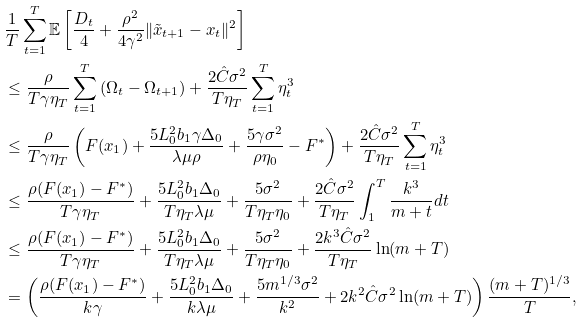<formula> <loc_0><loc_0><loc_500><loc_500>& \frac { 1 } { T } \sum _ { t = 1 } ^ { T } \mathbb { E } \left [ \frac { D _ { t } } { 4 } + \frac { \rho ^ { 2 } } { 4 \gamma ^ { 2 } } \| \tilde { x } _ { t + 1 } - x _ { t } \| ^ { 2 } \right ] \\ & \leq \frac { \rho } { T \gamma \eta _ { T } } \sum _ { t = 1 } ^ { T } \left ( \Omega _ { t } - \Omega _ { t + 1 } \right ) + \frac { 2 \hat { C } \sigma ^ { 2 } } { T \eta _ { T } } \sum _ { t = 1 } ^ { T } \eta ^ { 3 } _ { t } \\ & \leq \frac { \rho } { T \gamma \eta _ { T } } \left ( F ( x _ { 1 } ) + \frac { 5 L ^ { 2 } _ { 0 } b _ { 1 } \gamma \Delta _ { 0 } } { \lambda \mu \rho } + \frac { 5 \gamma \sigma ^ { 2 } } { \rho \eta _ { 0 } } - F ^ { * } \right ) + \frac { 2 \hat { C } \sigma ^ { 2 } } { T \eta _ { T } } \sum _ { t = 1 } ^ { T } \eta ^ { 3 } _ { t } \\ & \leq \frac { \rho ( F ( x _ { 1 } ) - F ^ { * } ) } { T \gamma \eta _ { T } } + \frac { 5 L ^ { 2 } _ { 0 } b _ { 1 } \Delta _ { 0 } } { T \eta _ { T } \lambda \mu } + \frac { 5 \sigma ^ { 2 } } { T \eta _ { T } \eta _ { 0 } } + \frac { 2 \hat { C } \sigma ^ { 2 } } { T \eta _ { T } } \int ^ { T } _ { 1 } \frac { k ^ { 3 } } { m + t } d t \\ & \leq \frac { \rho ( F ( x _ { 1 } ) - F ^ { * } ) } { T \gamma \eta _ { T } } + \frac { 5 L ^ { 2 } _ { 0 } b _ { 1 } \Delta _ { 0 } } { T \eta _ { T } \lambda \mu } + \frac { 5 \sigma ^ { 2 } } { T \eta _ { T } \eta _ { 0 } } + \frac { 2 k ^ { 3 } \hat { C } \sigma ^ { 2 } } { T \eta _ { T } } \ln ( m + T ) \\ & = \left ( \frac { \rho ( F ( x _ { 1 } ) - F ^ { * } ) } { k \gamma } + \frac { 5 L ^ { 2 } _ { 0 } b _ { 1 } \Delta _ { 0 } } { k \lambda \mu } + \frac { 5 m ^ { 1 / 3 } \sigma ^ { 2 } } { k ^ { 2 } } + 2 k ^ { 2 } \hat { C } \sigma ^ { 2 } \ln ( m + T ) \right ) \frac { ( m + T ) ^ { 1 / 3 } } { T } ,</formula> 